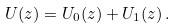<formula> <loc_0><loc_0><loc_500><loc_500>U ( z ) = U _ { 0 } ( z ) + U _ { 1 } ( z ) \, .</formula> 